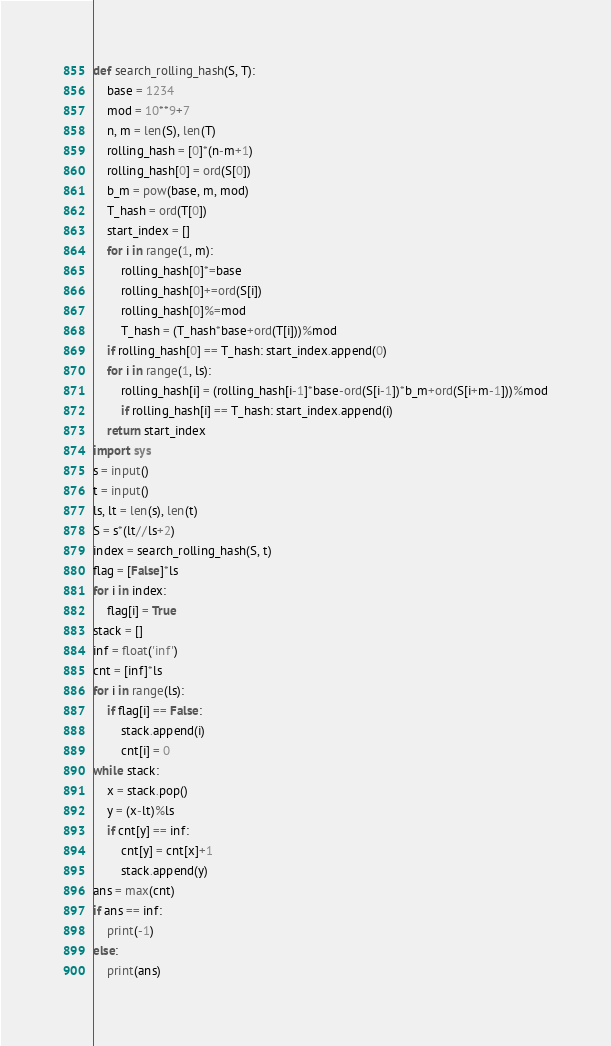<code> <loc_0><loc_0><loc_500><loc_500><_Python_>
def search_rolling_hash(S, T):
    base = 1234
    mod = 10**9+7
    n, m = len(S), len(T)
    rolling_hash = [0]*(n-m+1)  
    rolling_hash[0] = ord(S[0])
    b_m = pow(base, m, mod)
    T_hash = ord(T[0])
    start_index = []
    for i in range(1, m):
        rolling_hash[0]*=base
        rolling_hash[0]+=ord(S[i])
        rolling_hash[0]%=mod
        T_hash = (T_hash*base+ord(T[i]))%mod
    if rolling_hash[0] == T_hash: start_index.append(0)
    for i in range(1, ls):
        rolling_hash[i] = (rolling_hash[i-1]*base-ord(S[i-1])*b_m+ord(S[i+m-1]))%mod
        if rolling_hash[i] == T_hash: start_index.append(i)
    return start_index
import sys
s = input()
t = input()
ls, lt = len(s), len(t)
S = s*(lt//ls+2)
index = search_rolling_hash(S, t)
flag = [False]*ls
for i in index:
    flag[i] = True
stack = []
inf = float('inf')
cnt = [inf]*ls
for i in range(ls):
    if flag[i] == False:
        stack.append(i)
        cnt[i] = 0
while stack:
    x = stack.pop()
    y = (x-lt)%ls
    if cnt[y] == inf:
        cnt[y] = cnt[x]+1
        stack.append(y)
ans = max(cnt)
if ans == inf:
    print(-1)
else:
    print(ans)</code> 